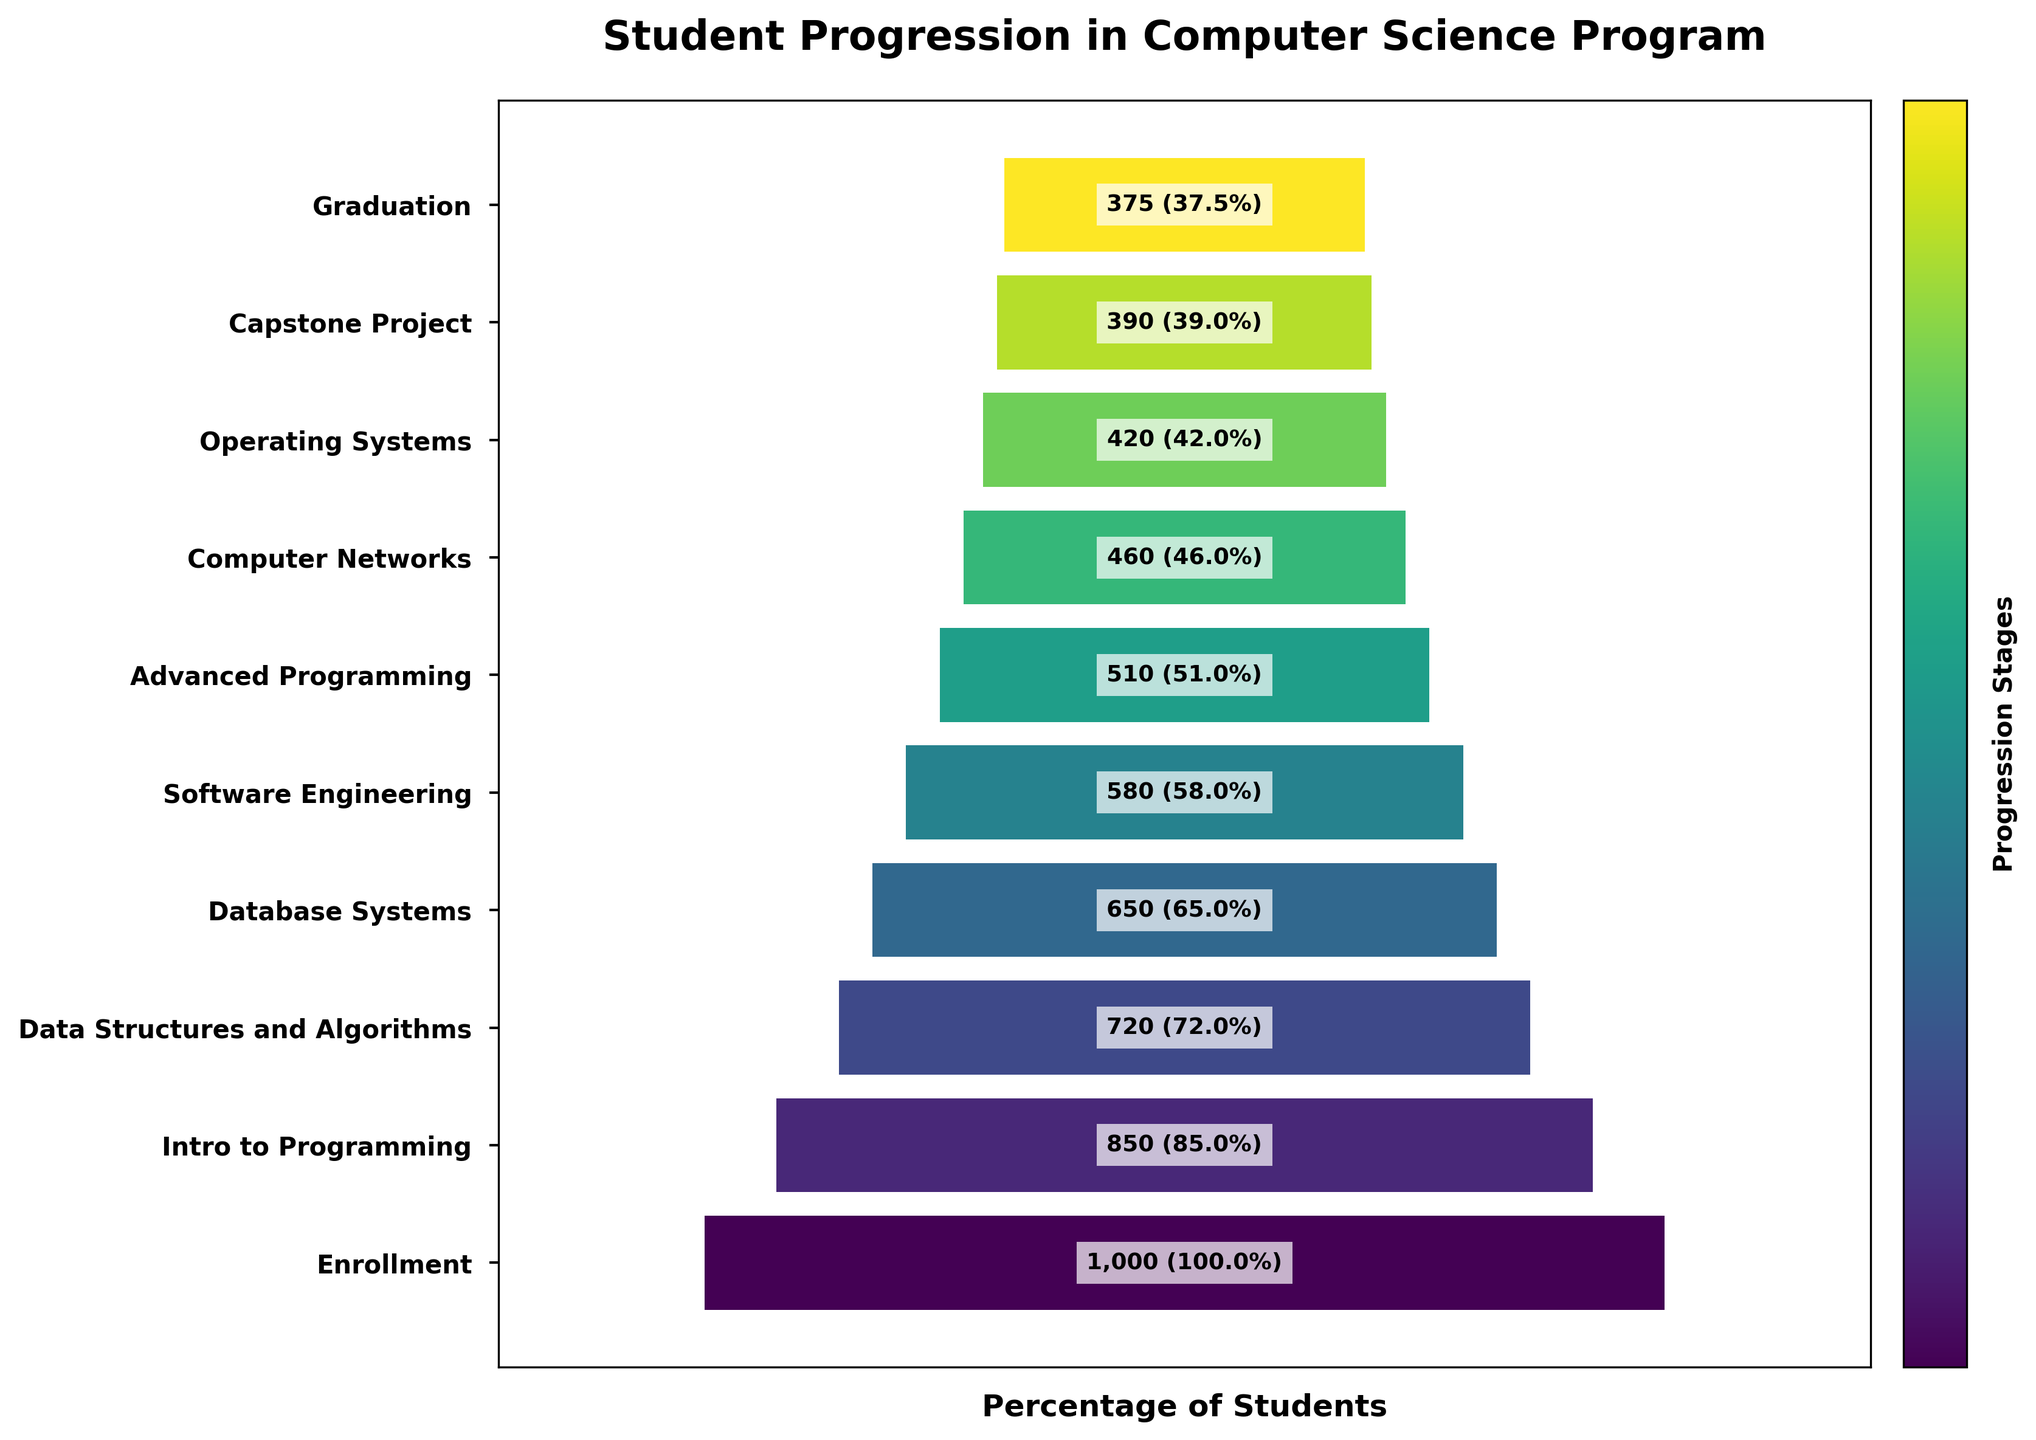What is the title of the Funnel Chart? The title is usually found at the top of the chart. It summarizes the main topic of the chart. In this case, the title is "Student Progression in Computer Science Program" as seen at the top.
Answer: Student Progression in Computer Science Program How many students enrolled in the computer science program? The first stage of the funnel chart typically represents the initial count of participants. Here, the first bar labeled "Enrollment" shows 1000 students.
Answer: 1000 What percentage of students progressed from Enrollment to Intro to Programming? The second bar in the funnel chart, "Intro to Programming," has 850 students. To find the percentage, we divide 850 by 1000 and multiply by 100. (850 / 1000) * 100 = 85%.
Answer: 85% Which stage has the highest dropout rate after Enrollment? To find the highest dropout rate, we need to look at the differences between consecutive stages. The most significant drop in the count of students is from "Intro to Programming" (850) to "Data Structures and Algorithms" (720), a drop of 130 students.
Answer: Intro to Programming to Data Structures and Algorithms How many students reach the Capstone Project stage? The number of students is directly labeled on the bar for each stage. The bar for "Capstone Project" shows 390 students.
Answer: 390 What is the total number of students that drop out between Enrollment and Graduation? You subtract the number of students at the Graduation stage from the number at the Enrollment stage (1000 - 375).
Answer: 625 What is the percentage of students that graduate from the computer science program? The final bar "Graduation" shows 375 students out of the initial 1000. To find the percentage, you divide 375 by 1000 and multiply by 100. (375 / 1000) * 100 = 37.5%.
Answer: 37.5% Which stage has the smallest number of students progressing to the next stage? To determine this, compare the drop in student numbers between each consecutive stage. The smallest progression occurs between "Operating Systems" (420) and "Capstone Project" (390), a drop of 30 students.
Answer: Operating Systems to Capstone Project By what percentage does the number of students decrease from Software Engineering to Advanced Programming? The number of students decreases from 580 to 510. The percentage decrease is calculated as [(580 - 510) / 580] * 100 = 12.1%.
Answer: 12.1% Between which two stages is there the least percentage of students dropping out? Calculate the percentage difference between consecutive stages, the smallest percentage drop is between "Capstone Project" (390) and "Graduation" (375) [(390 - 375) / 390] * 100 = 3.8%.
Answer: Capstone Project to Graduation 